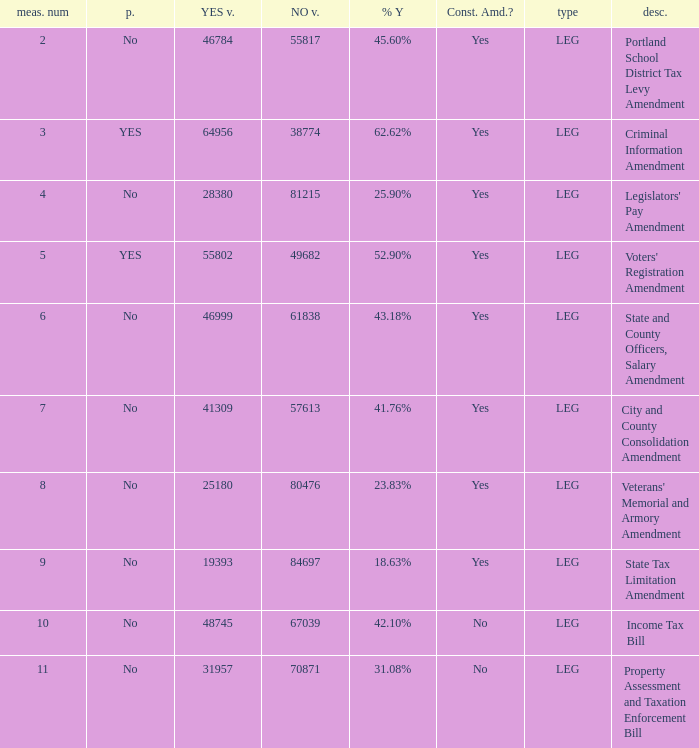Who had 41.76% yes votes City and County Consolidation Amendment. 